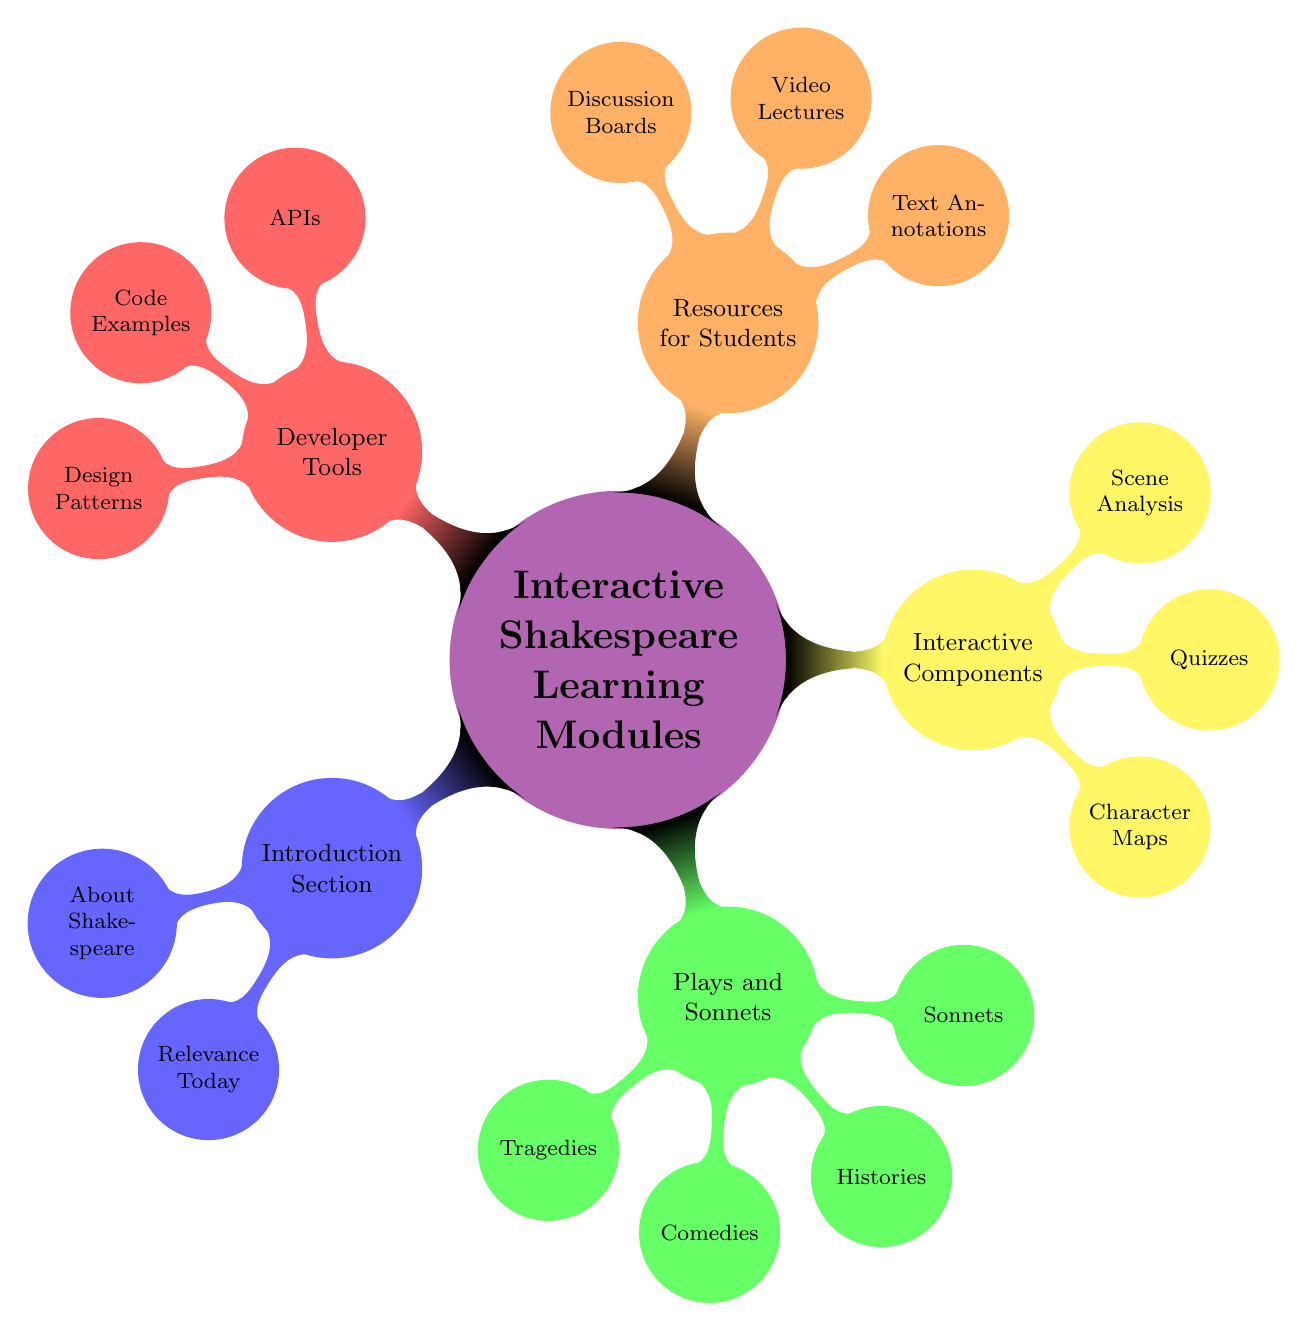What is the color associated with the "Introduction Section"? The "Introduction Section" is represented in blue!60 as seen in the mind map.
Answer: blue!60 How many types of plays are listed under "Plays and Sonnets"? There are four types of plays listed: Tragedies, Comedies, Histories, and Sonnets, which gives a total of four nodes.
Answer: four What interactive component can help visualize character relationships? The component "Character Maps" provides interactive diagrams to visualize character relationships, as mentioned in the diagram.
Answer: Character Maps What are the two main categories under "Resources for Students"? The categories under "Resources for Students" include Text Annotations and Video Lectures, making it two main categories in total.
Answer: Text Annotations and Video Lectures Which section contains quizzes for knowledge checks? The "Interactive Components" section includes quizzes specifically designed for knowledge checks.
Answer: Interactive Components What is the total number of nodes in the "Developer Tools" section? The "Developer Tools" section includes three nodes: APIs, Code Examples, and Design Patterns, hence the total is three.
Answer: three Which module provides a detailed look at pivotal scenes? The module "Scene Analysis" is specifically designed to provide a detailed look at pivotal scenes according to the diagram.
Answer: Scene Analysis How can developers integrate tools according to the mind map? Developers can integrate tools using the "APIs" found in the "Developer Tools" section, as indicated in the diagram.
Answer: APIs What is the main focus of the "About Shakespeare" node? The "About Shakespeare" node focuses on the life and work of William Shakespeare, giving an overview of his background.
Answer: Life and work of William Shakespeare 